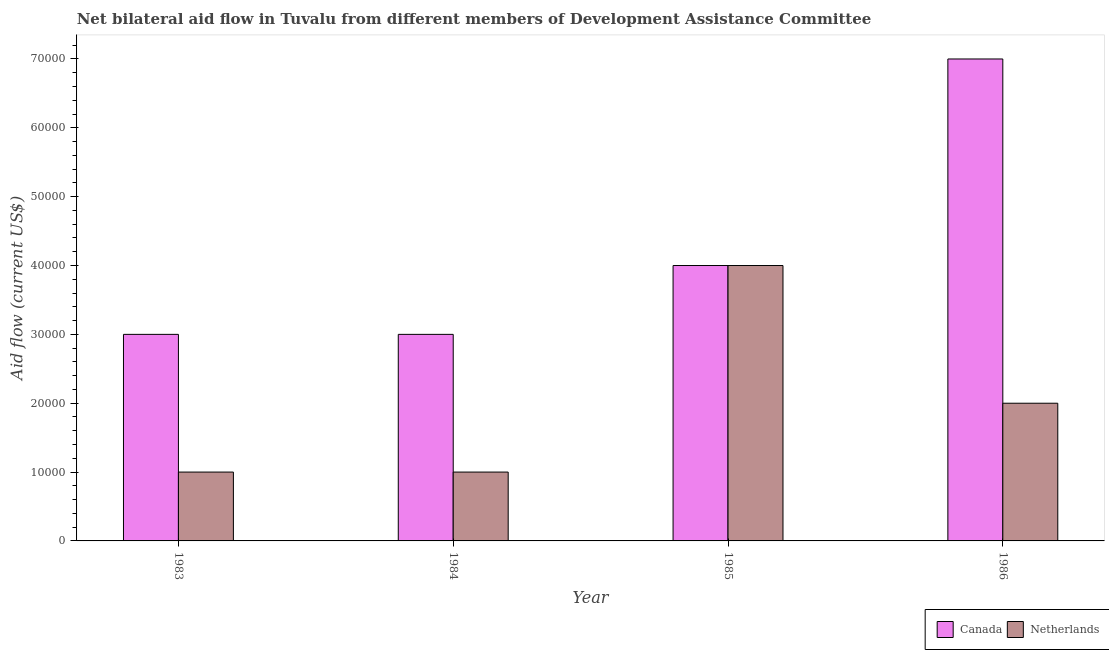How many different coloured bars are there?
Offer a terse response. 2. How many bars are there on the 1st tick from the right?
Your answer should be very brief. 2. What is the amount of aid given by netherlands in 1984?
Give a very brief answer. 10000. Across all years, what is the maximum amount of aid given by netherlands?
Provide a succinct answer. 4.00e+04. Across all years, what is the minimum amount of aid given by netherlands?
Ensure brevity in your answer.  10000. In which year was the amount of aid given by canada maximum?
Give a very brief answer. 1986. What is the total amount of aid given by canada in the graph?
Ensure brevity in your answer.  1.70e+05. What is the difference between the amount of aid given by canada in 1984 and that in 1985?
Offer a very short reply. -10000. What is the difference between the amount of aid given by canada in 1986 and the amount of aid given by netherlands in 1985?
Provide a succinct answer. 3.00e+04. What is the ratio of the amount of aid given by canada in 1984 to that in 1986?
Make the answer very short. 0.43. Is the amount of aid given by netherlands in 1983 less than that in 1984?
Provide a short and direct response. No. Is the difference between the amount of aid given by netherlands in 1983 and 1986 greater than the difference between the amount of aid given by canada in 1983 and 1986?
Offer a very short reply. No. What is the difference between the highest and the lowest amount of aid given by canada?
Provide a succinct answer. 4.00e+04. In how many years, is the amount of aid given by canada greater than the average amount of aid given by canada taken over all years?
Provide a succinct answer. 1. Is the sum of the amount of aid given by canada in 1985 and 1986 greater than the maximum amount of aid given by netherlands across all years?
Provide a short and direct response. Yes. What does the 1st bar from the right in 1985 represents?
Give a very brief answer. Netherlands. Are all the bars in the graph horizontal?
Give a very brief answer. No. How many years are there in the graph?
Make the answer very short. 4. Are the values on the major ticks of Y-axis written in scientific E-notation?
Make the answer very short. No. Does the graph contain grids?
Your answer should be compact. No. Where does the legend appear in the graph?
Provide a succinct answer. Bottom right. How are the legend labels stacked?
Your response must be concise. Horizontal. What is the title of the graph?
Provide a succinct answer. Net bilateral aid flow in Tuvalu from different members of Development Assistance Committee. Does "GDP" appear as one of the legend labels in the graph?
Ensure brevity in your answer.  No. What is the label or title of the X-axis?
Your answer should be compact. Year. What is the label or title of the Y-axis?
Your answer should be very brief. Aid flow (current US$). What is the Aid flow (current US$) in Netherlands in 1985?
Keep it short and to the point. 4.00e+04. What is the Aid flow (current US$) in Canada in 1986?
Keep it short and to the point. 7.00e+04. Across all years, what is the minimum Aid flow (current US$) of Canada?
Offer a very short reply. 3.00e+04. What is the total Aid flow (current US$) in Canada in the graph?
Offer a very short reply. 1.70e+05. What is the difference between the Aid flow (current US$) of Canada in 1983 and that in 1984?
Your response must be concise. 0. What is the difference between the Aid flow (current US$) in Netherlands in 1983 and that in 1984?
Keep it short and to the point. 0. What is the difference between the Aid flow (current US$) in Netherlands in 1983 and that in 1985?
Provide a short and direct response. -3.00e+04. What is the difference between the Aid flow (current US$) of Canada in 1983 and that in 1986?
Your response must be concise. -4.00e+04. What is the difference between the Aid flow (current US$) of Canada in 1984 and that in 1985?
Give a very brief answer. -10000. What is the difference between the Aid flow (current US$) in Netherlands in 1984 and that in 1985?
Keep it short and to the point. -3.00e+04. What is the difference between the Aid flow (current US$) in Canada in 1984 and that in 1986?
Offer a terse response. -4.00e+04. What is the difference between the Aid flow (current US$) of Canada in 1984 and the Aid flow (current US$) of Netherlands in 1985?
Offer a terse response. -10000. What is the difference between the Aid flow (current US$) of Canada in 1984 and the Aid flow (current US$) of Netherlands in 1986?
Keep it short and to the point. 10000. What is the average Aid flow (current US$) of Canada per year?
Give a very brief answer. 4.25e+04. What is the average Aid flow (current US$) of Netherlands per year?
Ensure brevity in your answer.  2.00e+04. In the year 1985, what is the difference between the Aid flow (current US$) in Canada and Aid flow (current US$) in Netherlands?
Your response must be concise. 0. What is the ratio of the Aid flow (current US$) of Canada in 1983 to that in 1984?
Give a very brief answer. 1. What is the ratio of the Aid flow (current US$) in Canada in 1983 to that in 1986?
Offer a terse response. 0.43. What is the ratio of the Aid flow (current US$) of Netherlands in 1983 to that in 1986?
Your answer should be compact. 0.5. What is the ratio of the Aid flow (current US$) of Canada in 1984 to that in 1985?
Make the answer very short. 0.75. What is the ratio of the Aid flow (current US$) of Netherlands in 1984 to that in 1985?
Ensure brevity in your answer.  0.25. What is the ratio of the Aid flow (current US$) of Canada in 1984 to that in 1986?
Offer a terse response. 0.43. What is the ratio of the Aid flow (current US$) in Netherlands in 1984 to that in 1986?
Keep it short and to the point. 0.5. What is the ratio of the Aid flow (current US$) in Netherlands in 1985 to that in 1986?
Provide a succinct answer. 2. What is the difference between the highest and the second highest Aid flow (current US$) of Canada?
Offer a very short reply. 3.00e+04. 